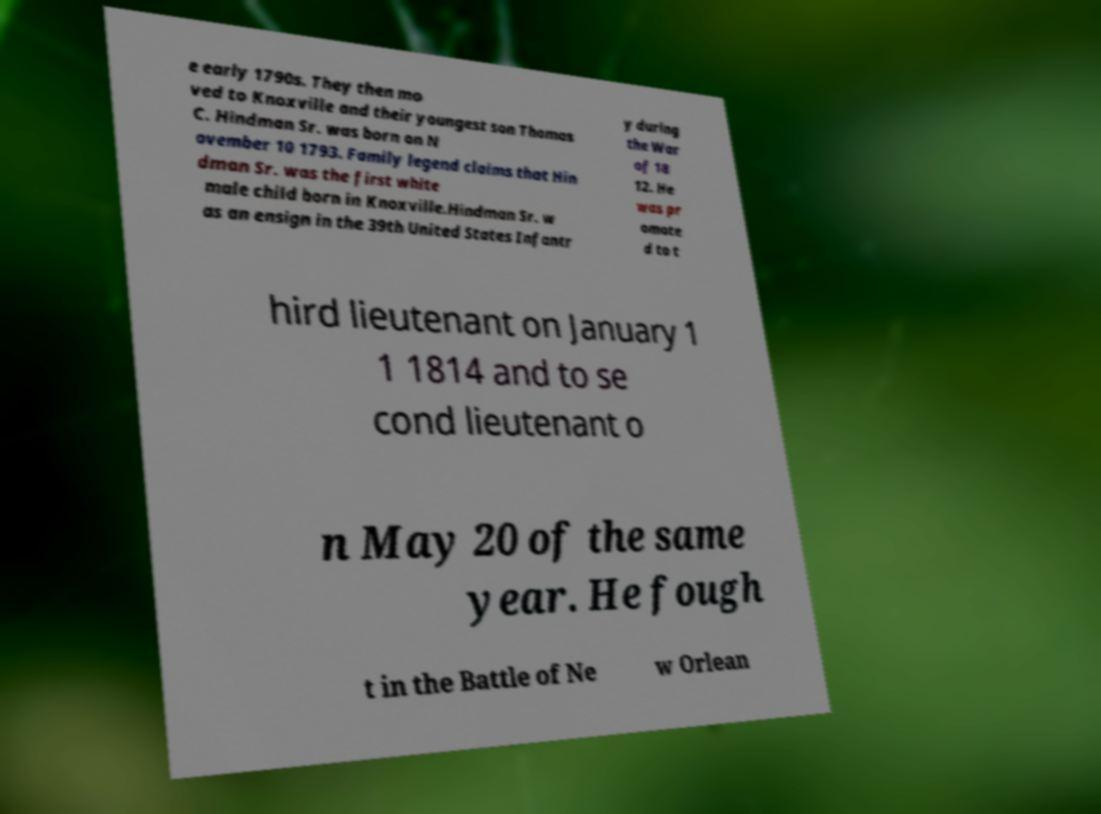What messages or text are displayed in this image? I need them in a readable, typed format. e early 1790s. They then mo ved to Knoxville and their youngest son Thomas C. Hindman Sr. was born on N ovember 10 1793. Family legend claims that Hin dman Sr. was the first white male child born in Knoxville.Hindman Sr. w as an ensign in the 39th United States Infantr y during the War of 18 12. He was pr omote d to t hird lieutenant on January 1 1 1814 and to se cond lieutenant o n May 20 of the same year. He fough t in the Battle of Ne w Orlean 